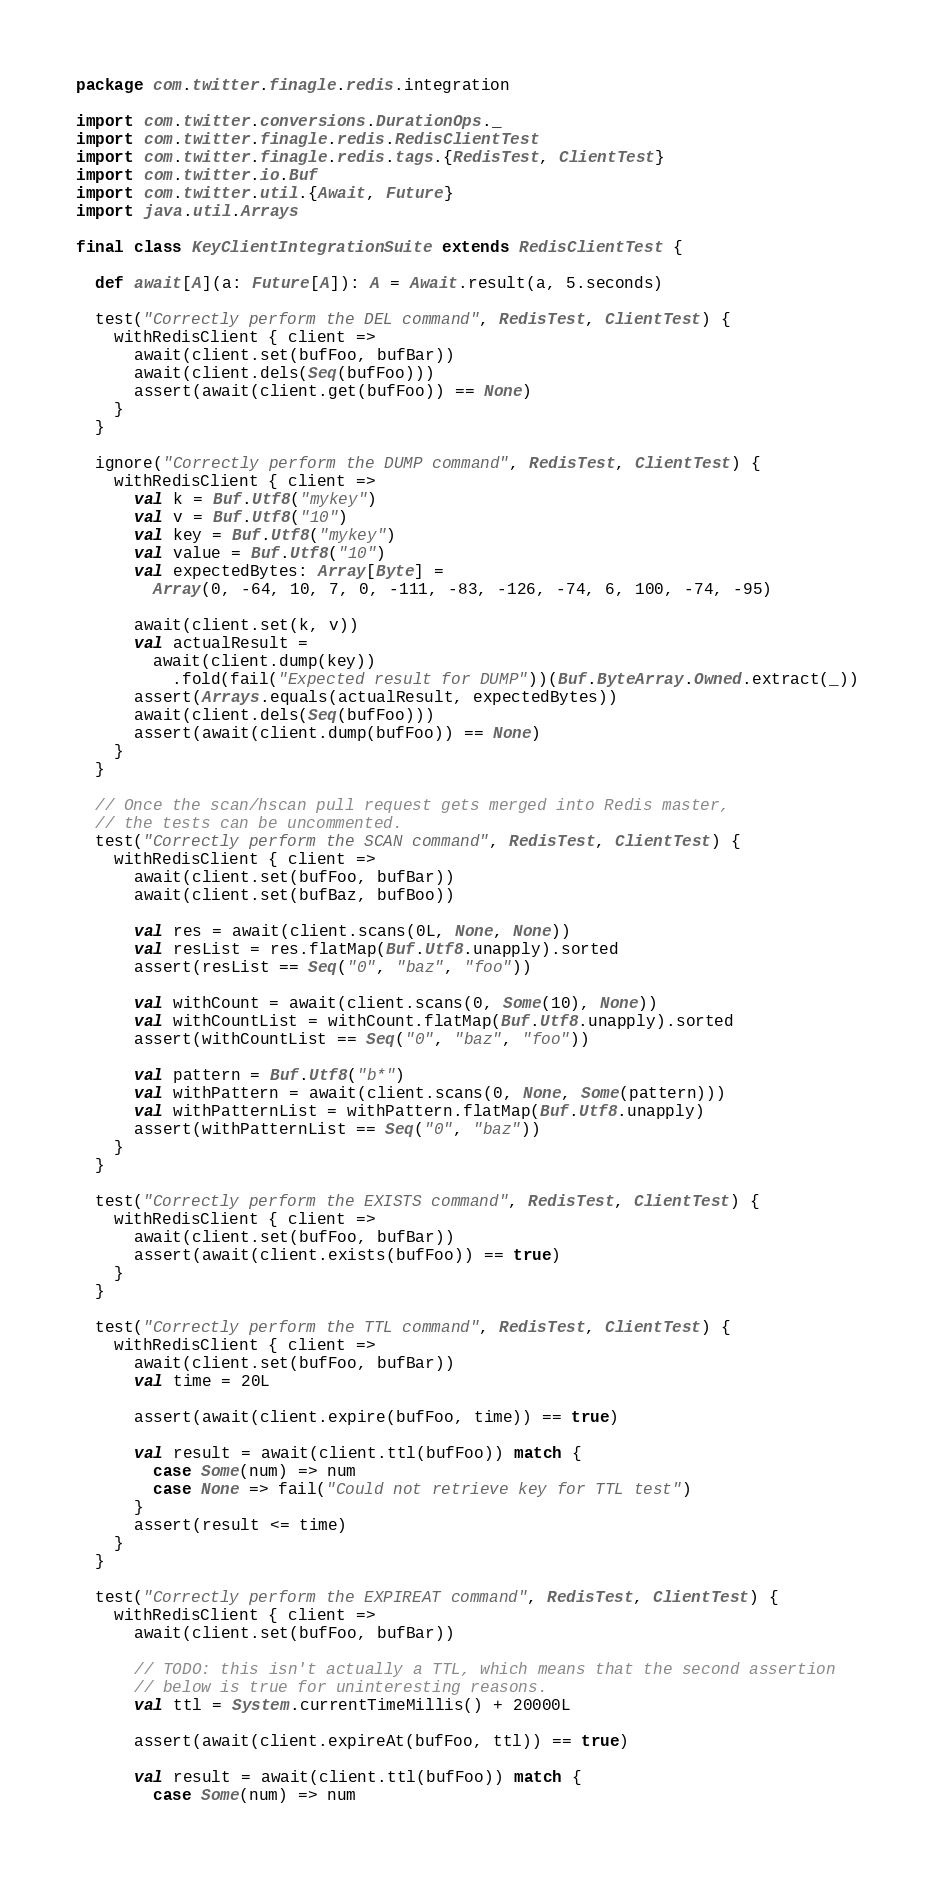Convert code to text. <code><loc_0><loc_0><loc_500><loc_500><_Scala_>package com.twitter.finagle.redis.integration

import com.twitter.conversions.DurationOps._
import com.twitter.finagle.redis.RedisClientTest
import com.twitter.finagle.redis.tags.{RedisTest, ClientTest}
import com.twitter.io.Buf
import com.twitter.util.{Await, Future}
import java.util.Arrays

final class KeyClientIntegrationSuite extends RedisClientTest {

  def await[A](a: Future[A]): A = Await.result(a, 5.seconds)

  test("Correctly perform the DEL command", RedisTest, ClientTest) {
    withRedisClient { client =>
      await(client.set(bufFoo, bufBar))
      await(client.dels(Seq(bufFoo)))
      assert(await(client.get(bufFoo)) == None)
    }
  }

  ignore("Correctly perform the DUMP command", RedisTest, ClientTest) {
    withRedisClient { client =>
      val k = Buf.Utf8("mykey")
      val v = Buf.Utf8("10")
      val key = Buf.Utf8("mykey")
      val value = Buf.Utf8("10")
      val expectedBytes: Array[Byte] =
        Array(0, -64, 10, 7, 0, -111, -83, -126, -74, 6, 100, -74, -95)

      await(client.set(k, v))
      val actualResult =
        await(client.dump(key))
          .fold(fail("Expected result for DUMP"))(Buf.ByteArray.Owned.extract(_))
      assert(Arrays.equals(actualResult, expectedBytes))
      await(client.dels(Seq(bufFoo)))
      assert(await(client.dump(bufFoo)) == None)
    }
  }

  // Once the scan/hscan pull request gets merged into Redis master,
  // the tests can be uncommented.
  test("Correctly perform the SCAN command", RedisTest, ClientTest) {
    withRedisClient { client =>
      await(client.set(bufFoo, bufBar))
      await(client.set(bufBaz, bufBoo))

      val res = await(client.scans(0L, None, None))
      val resList = res.flatMap(Buf.Utf8.unapply).sorted
      assert(resList == Seq("0", "baz", "foo"))

      val withCount = await(client.scans(0, Some(10), None))
      val withCountList = withCount.flatMap(Buf.Utf8.unapply).sorted
      assert(withCountList == Seq("0", "baz", "foo"))

      val pattern = Buf.Utf8("b*")
      val withPattern = await(client.scans(0, None, Some(pattern)))
      val withPatternList = withPattern.flatMap(Buf.Utf8.unapply)
      assert(withPatternList == Seq("0", "baz"))
    }
  }

  test("Correctly perform the EXISTS command", RedisTest, ClientTest) {
    withRedisClient { client =>
      await(client.set(bufFoo, bufBar))
      assert(await(client.exists(bufFoo)) == true)
    }
  }

  test("Correctly perform the TTL command", RedisTest, ClientTest) {
    withRedisClient { client =>
      await(client.set(bufFoo, bufBar))
      val time = 20L

      assert(await(client.expire(bufFoo, time)) == true)

      val result = await(client.ttl(bufFoo)) match {
        case Some(num) => num
        case None => fail("Could not retrieve key for TTL test")
      }
      assert(result <= time)
    }
  }

  test("Correctly perform the EXPIREAT command", RedisTest, ClientTest) {
    withRedisClient { client =>
      await(client.set(bufFoo, bufBar))

      // TODO: this isn't actually a TTL, which means that the second assertion
      // below is true for uninteresting reasons.
      val ttl = System.currentTimeMillis() + 20000L

      assert(await(client.expireAt(bufFoo, ttl)) == true)

      val result = await(client.ttl(bufFoo)) match {
        case Some(num) => num</code> 